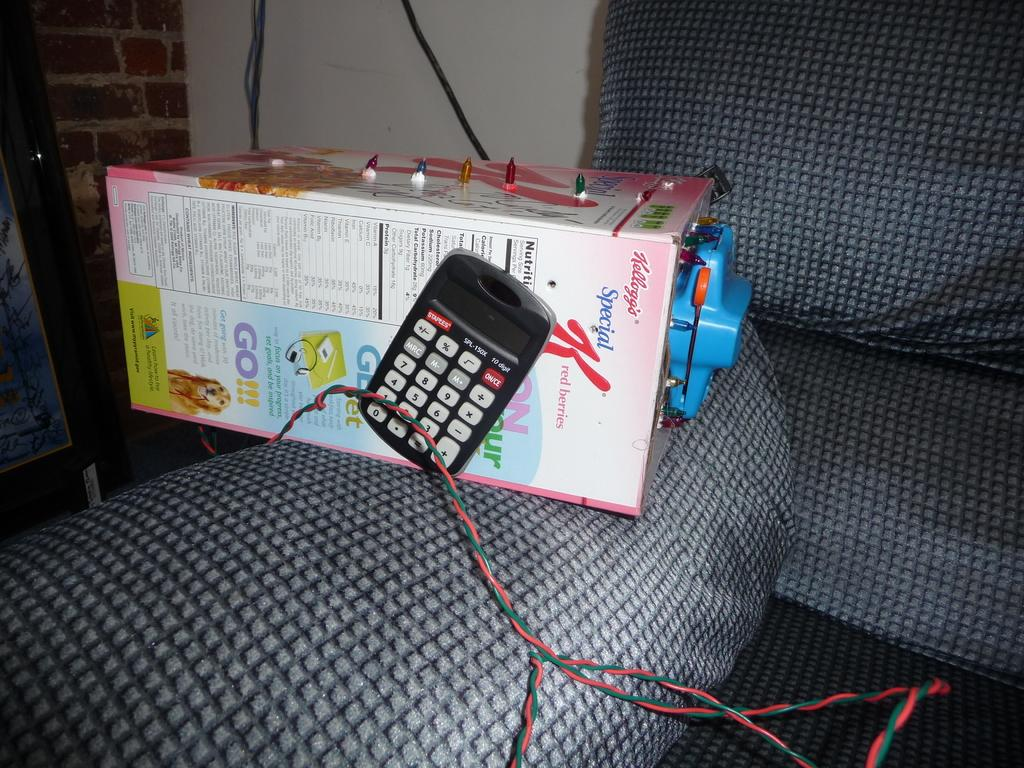<image>
Share a concise interpretation of the image provided. Black calculator next to a large Kelloggs Special K box. 